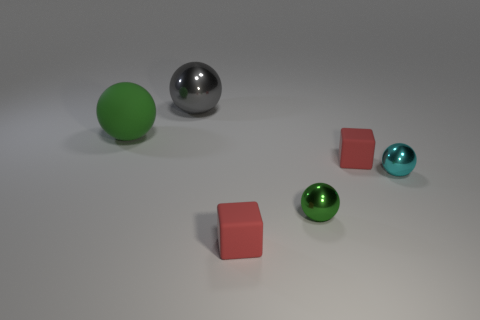What is the shape of the tiny green object that is the same material as the cyan ball?
Make the answer very short. Sphere. There is a rubber object on the left side of the big object that is on the right side of the large green matte thing; how big is it?
Make the answer very short. Large. The sphere that is behind the big matte thing is what color?
Offer a very short reply. Gray. Are there any large gray metal objects that have the same shape as the small green thing?
Your response must be concise. Yes. Is the number of large green matte balls on the right side of the matte sphere less than the number of matte spheres that are behind the cyan sphere?
Ensure brevity in your answer.  Yes. What color is the large matte thing?
Your answer should be very brief. Green. There is a green thing that is in front of the large green rubber thing; is there a cube to the right of it?
Your response must be concise. Yes. How many other green things have the same size as the green metal thing?
Keep it short and to the point. 0. There is a red matte block that is on the right side of the green object in front of the rubber ball; what number of small red rubber cubes are in front of it?
Your answer should be compact. 1. What number of spheres are to the left of the cyan thing and right of the gray thing?
Your answer should be very brief. 1. 